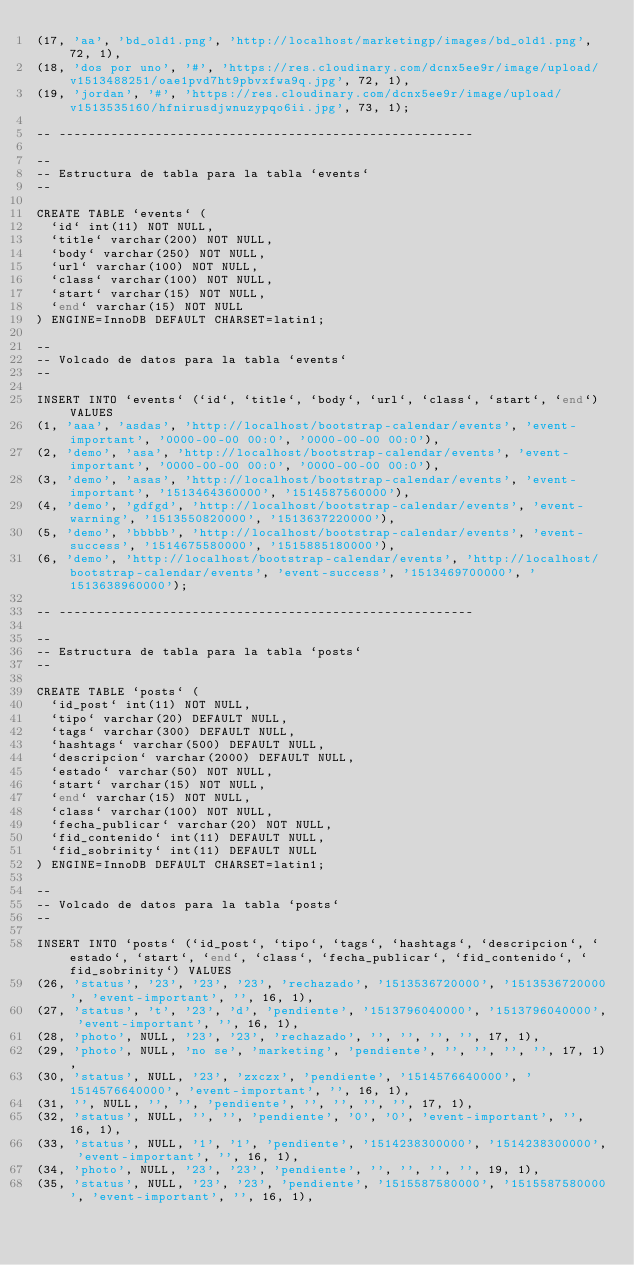<code> <loc_0><loc_0><loc_500><loc_500><_SQL_>(17, 'aa', 'bd_old1.png', 'http://localhost/marketingp/images/bd_old1.png', 72, 1),
(18, 'dos por uno', '#', 'https://res.cloudinary.com/dcnx5ee9r/image/upload/v1513488251/oae1pvd7ht9pbvxfwa9q.jpg', 72, 1),
(19, 'jordan', '#', 'https://res.cloudinary.com/dcnx5ee9r/image/upload/v1513535160/hfnirusdjwnuzypqo6ii.jpg', 73, 1);

-- --------------------------------------------------------

--
-- Estructura de tabla para la tabla `events`
--

CREATE TABLE `events` (
  `id` int(11) NOT NULL,
  `title` varchar(200) NOT NULL,
  `body` varchar(250) NOT NULL,
  `url` varchar(100) NOT NULL,
  `class` varchar(100) NOT NULL,
  `start` varchar(15) NOT NULL,
  `end` varchar(15) NOT NULL
) ENGINE=InnoDB DEFAULT CHARSET=latin1;

--
-- Volcado de datos para la tabla `events`
--

INSERT INTO `events` (`id`, `title`, `body`, `url`, `class`, `start`, `end`) VALUES
(1, 'aaa', 'asdas', 'http://localhost/bootstrap-calendar/events', 'event-important', '0000-00-00 00:0', '0000-00-00 00:0'),
(2, 'demo', 'asa', 'http://localhost/bootstrap-calendar/events', 'event-important', '0000-00-00 00:0', '0000-00-00 00:0'),
(3, 'demo', 'asas', 'http://localhost/bootstrap-calendar/events', 'event-important', '1513464360000', '1514587560000'),
(4, 'demo', 'gdfgd', 'http://localhost/bootstrap-calendar/events', 'event-warning', '1513550820000', '1513637220000'),
(5, 'demo', 'bbbbb', 'http://localhost/bootstrap-calendar/events', 'event-success', '1514675580000', '1515885180000'),
(6, 'demo', 'http://localhost/bootstrap-calendar/events', 'http://localhost/bootstrap-calendar/events', 'event-success', '1513469700000', '1513638960000');

-- --------------------------------------------------------

--
-- Estructura de tabla para la tabla `posts`
--

CREATE TABLE `posts` (
  `id_post` int(11) NOT NULL,
  `tipo` varchar(20) DEFAULT NULL,
  `tags` varchar(300) DEFAULT NULL,
  `hashtags` varchar(500) DEFAULT NULL,
  `descripcion` varchar(2000) DEFAULT NULL,
  `estado` varchar(50) NOT NULL,
  `start` varchar(15) NOT NULL,
  `end` varchar(15) NOT NULL,
  `class` varchar(100) NOT NULL,
  `fecha_publicar` varchar(20) NOT NULL,
  `fid_contenido` int(11) DEFAULT NULL,
  `fid_sobrinity` int(11) DEFAULT NULL
) ENGINE=InnoDB DEFAULT CHARSET=latin1;

--
-- Volcado de datos para la tabla `posts`
--

INSERT INTO `posts` (`id_post`, `tipo`, `tags`, `hashtags`, `descripcion`, `estado`, `start`, `end`, `class`, `fecha_publicar`, `fid_contenido`, `fid_sobrinity`) VALUES
(26, 'status', '23', '23', '23', 'rechazado', '1513536720000', '1513536720000', 'event-important', '', 16, 1),
(27, 'status', 't', '23', 'd', 'pendiente', '1513796040000', '1513796040000', 'event-important', '', 16, 1),
(28, 'photo', NULL, '23', '23', 'rechazado', '', '', '', '', 17, 1),
(29, 'photo', NULL, 'no se', 'marketing', 'pendiente', '', '', '', '', 17, 1),
(30, 'status', NULL, '23', 'zxczx', 'pendiente', '1514576640000', '1514576640000', 'event-important', '', 16, 1),
(31, '', NULL, '', '', 'pendiente', '', '', '', '', 17, 1),
(32, 'status', NULL, '', '', 'pendiente', '0', '0', 'event-important', '', 16, 1),
(33, 'status', NULL, '1', '1', 'pendiente', '1514238300000', '1514238300000', 'event-important', '', 16, 1),
(34, 'photo', NULL, '23', '23', 'pendiente', '', '', '', '', 19, 1),
(35, 'status', NULL, '23', '23', 'pendiente', '1515587580000', '1515587580000', 'event-important', '', 16, 1),</code> 